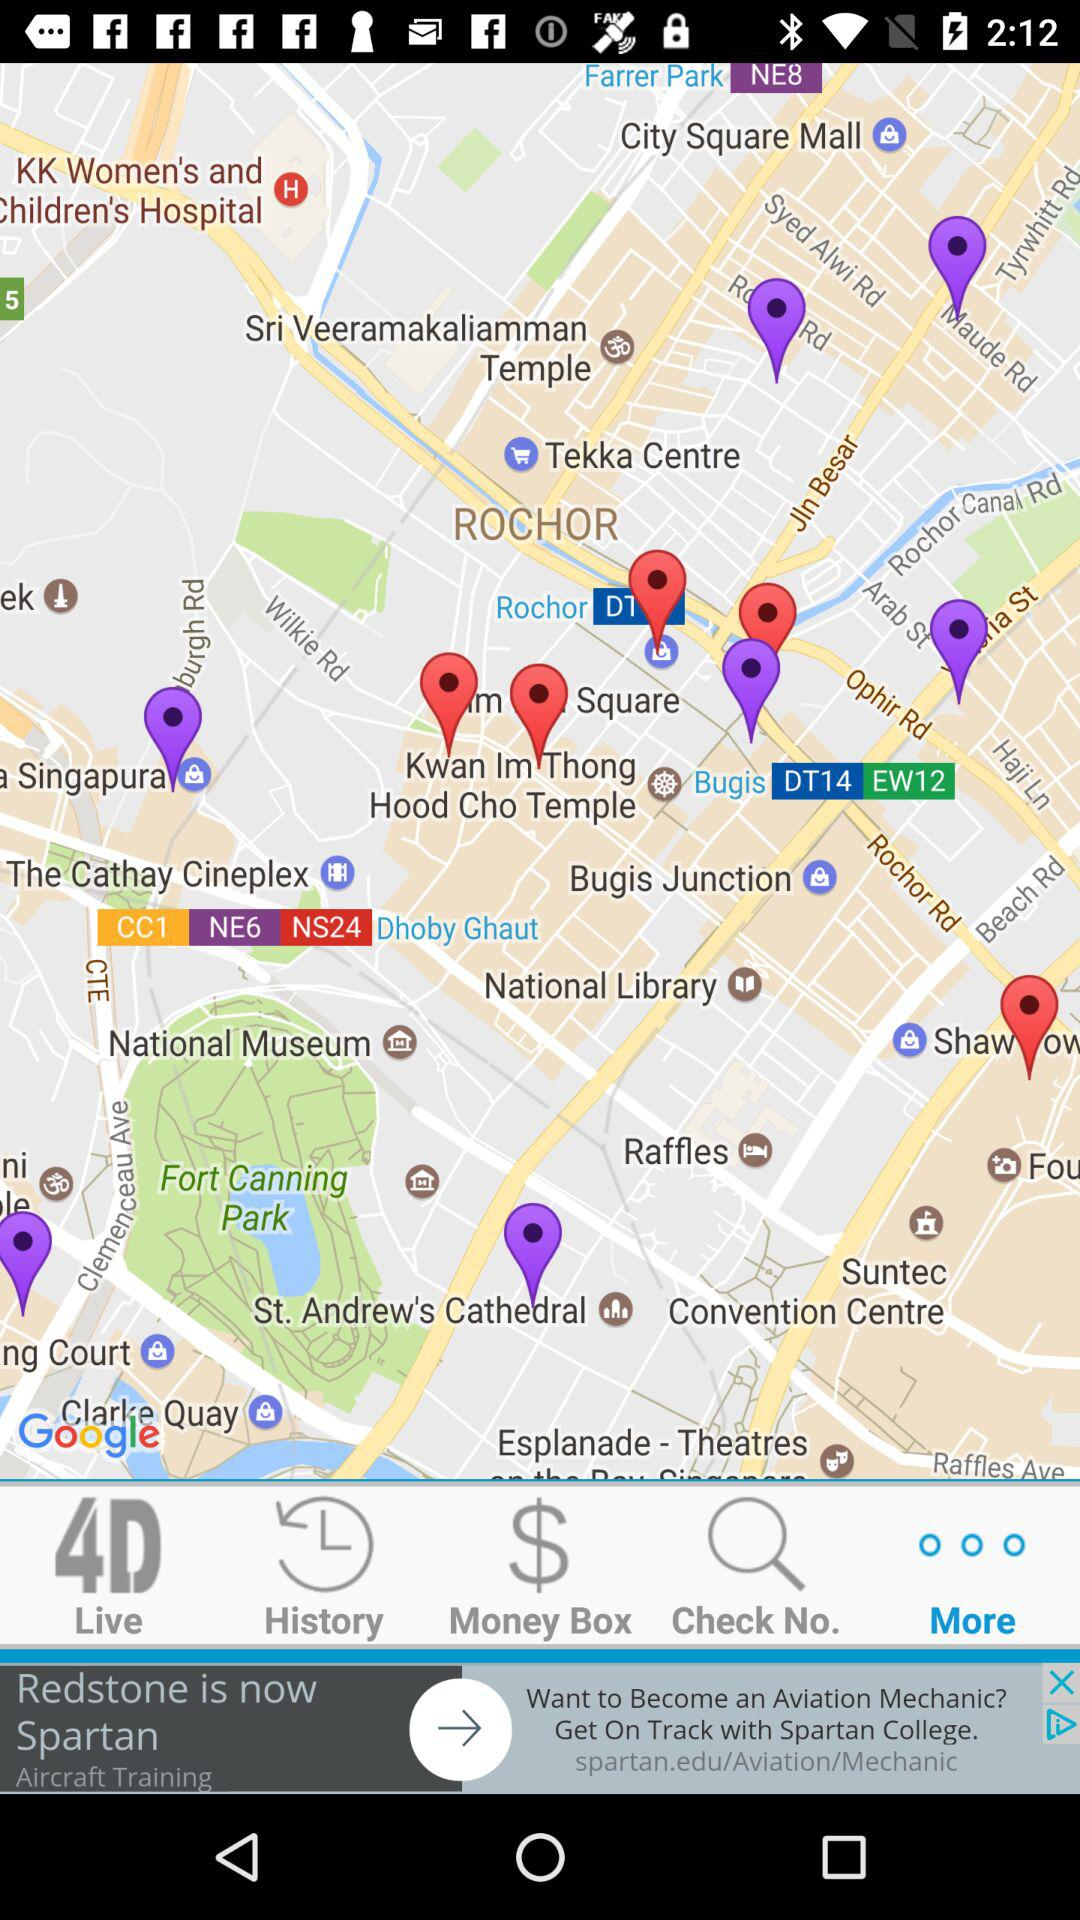Which tab is selected? The selected tab is "More". 